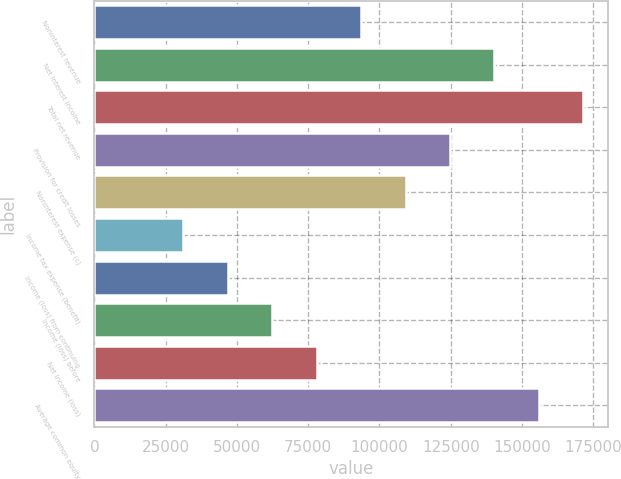<chart> <loc_0><loc_0><loc_500><loc_500><bar_chart><fcel>Noninterest revenue<fcel>Net interest income<fcel>Total net revenue<fcel>Provision for credit losses<fcel>Noninterest expense (c)<fcel>Income tax expense (benefit)<fcel>Income (loss) from continuing<fcel>Income (loss) before<fcel>Net income (loss)<fcel>Average common equity<nl><fcel>93582.6<fcel>140363<fcel>171551<fcel>124770<fcel>109176<fcel>31208.2<fcel>46801.8<fcel>62395.4<fcel>77989<fcel>155957<nl></chart> 